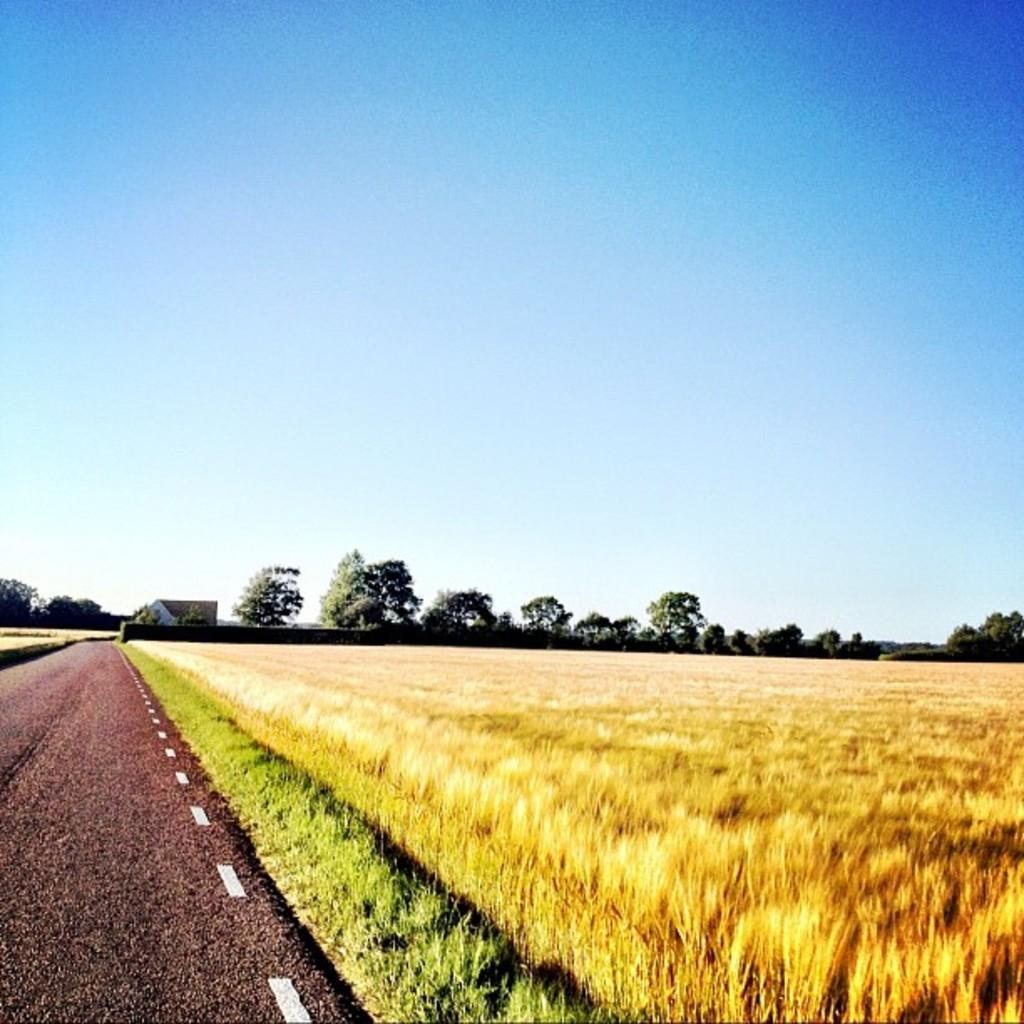What type of natural environment is depicted in the image? The image contains many trees, plants, and grass, which suggests a natural environment. What type of human-made structure can be seen in the image? There is a shed in the background of the image. What is the condition of the sky in the image? The sky is visible at the top of the image. What type of man-made feature is present on the left side of the image? There is a road on the left side of the image. What type of land is used for agricultural purposes in the image? There is farmland in the image. What type of picture is hanging on the wall in the image? There is no picture hanging on the wall in the image; the image only contains natural and man-made elements. What type of polish is being used to clean the shed in the image? There is no indication of any cleaning or polishing activity in the image, and the shed is not the main focus of the image. 